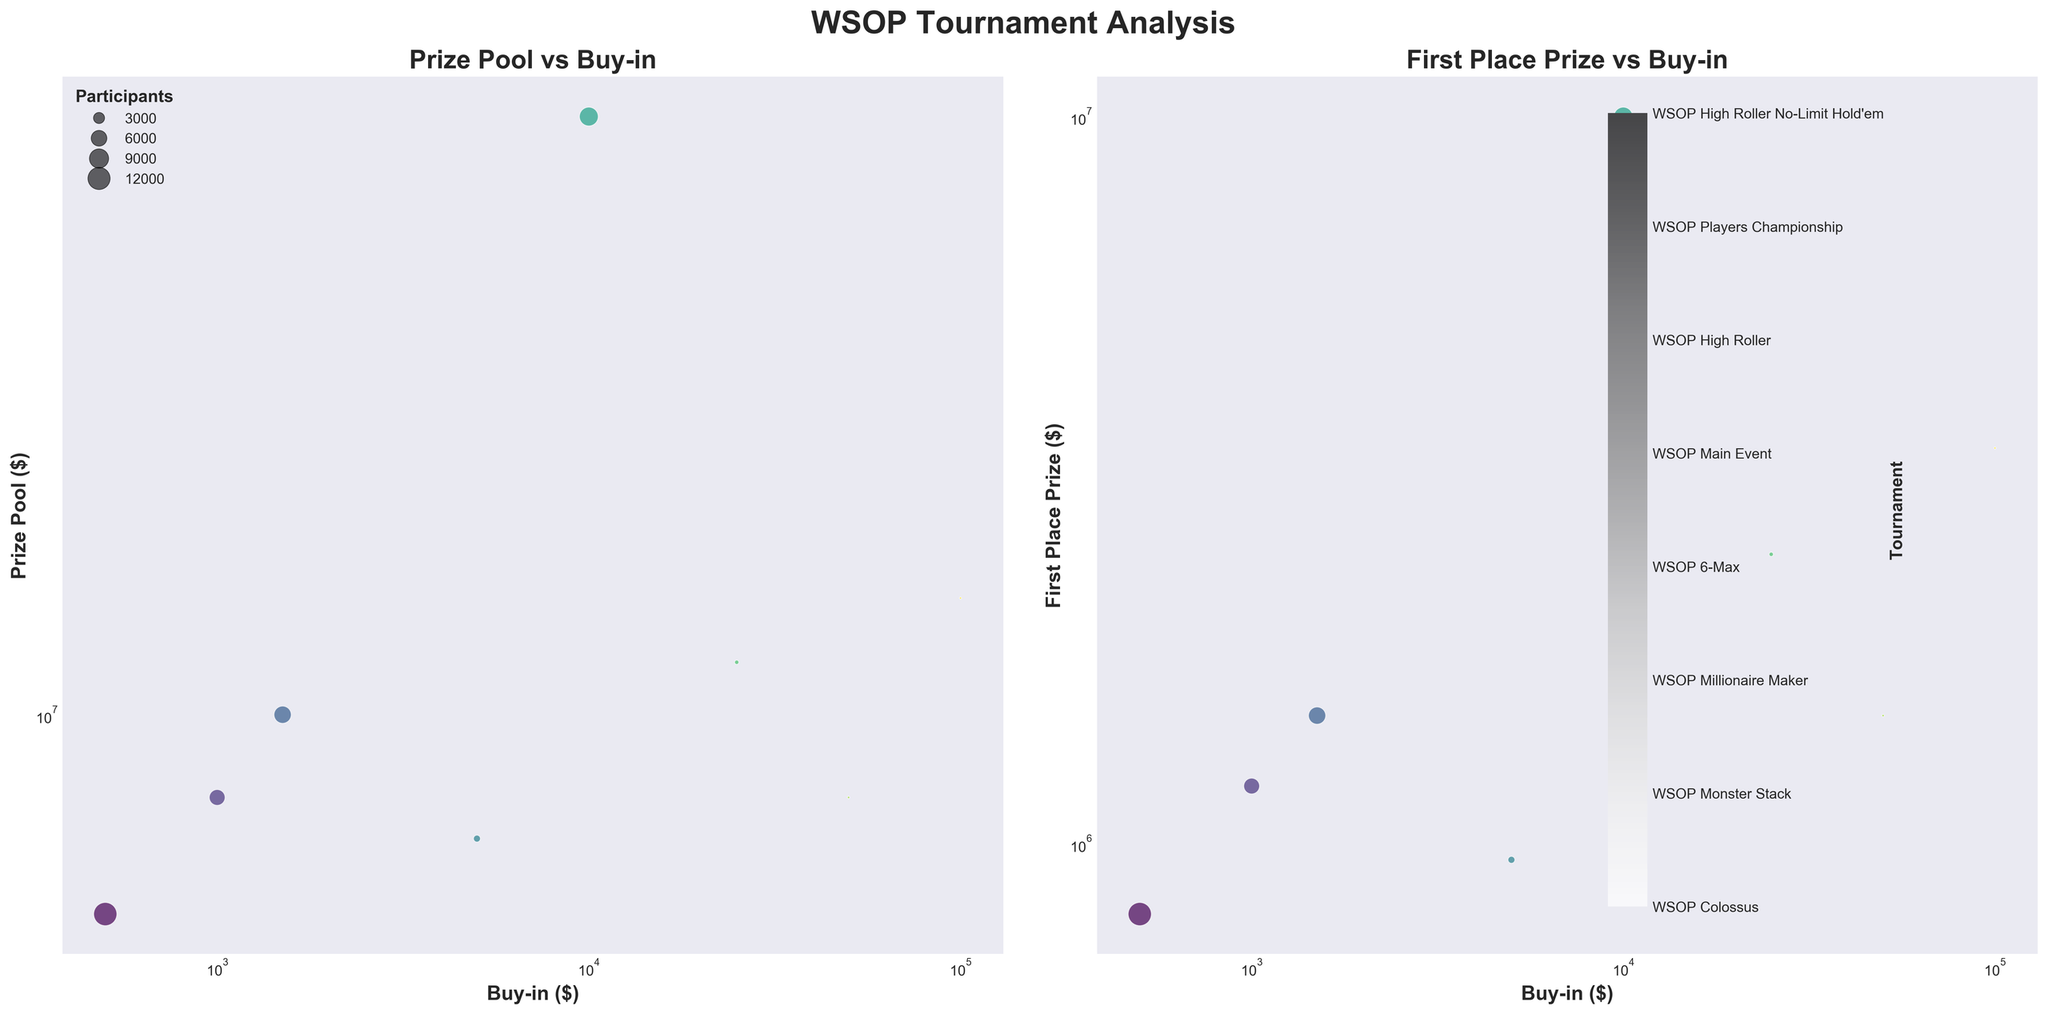What is the title of the entire plot? The main title is displayed at the top of the plot. It reads "WSOP Tournament Analysis".
Answer: WSOP Tournament Analysis What is the x-axis label of the first subplot? The label of the x-axis is written below the x-axis. It reads "Buy-in ($)".
Answer: Buy-in ($) How many data points are displayed in each subplot? By counting the number of bubbles in either the first or second subplot, you will find there are 8 data points represented by the bubbles.
Answer: 8 Which tournament has the largest bubble in the first subplot? The size of the bubble represents the number of participants. The largest bubble corresponds to the "WSOP Colossus" tournament with 13,070 participants.
Answer: WSOP Colossus Which tournament has the smallest first-place prize, and what is that amount? By referring to the second subplot, the smallest bubble on the first-place prize axis indicates the "WSOP 6-Max" tournament with a first-place prize of $950,000.
Answer: WSOP 6-Max, $950,000 What is the relationship between buy-in and prize pool in the first subplot? By observing the scatter plot, you can see that as the buy-in amount (x-axis) increases, the prize pool (y-axis) generally increases as well, indicating a positive relationship.
Answer: Positive relationship For the tournament with a $25,000 buy-in, what is the prize pool and number of participants? Look for the bubble representing the $25,000 buy-in in the first subplot and identify its prize pool and size. The prize pool is $12,000,000 and the number of participants is 421.
Answer: $12,000,000, 421 participants How does the prize pool of the WSOP Main Event compare to the WSOP Colossus? In the first subplot, the WSOP Main Event has a significantly larger prize pool ($80,000,000) compared to the WSOP Colossus ($5,000,000).
Answer: WSOP Main Event has a larger prize pool Calculate the average first-place prize for tournaments with a buy-in of $10,000 or more. First identify the relevant tournaments: WSOP Main Event ($10,000,000), WSOP High Roller ($2,500,000), WSOP Players Championship ($1,500,000), WSOP High Roller No-Limit Hold'em ($3,500,000). Sum these: $10,000,000 + $2,500,000 + $1,500,000 + $3,500,000 = $17,500,000. Divide by 4: $17,500,000 ÷ 4.
Answer: $4,375,000 Which tournament has the highest first-place prize, and what is its buy-in? In the second subplot, the highest point on the y-axis indicates the tournament with the highest first-place prize, which is the WSOP Main Event with a buy-in of $10,000.
Answer: WSOP Main Event, $10,000 